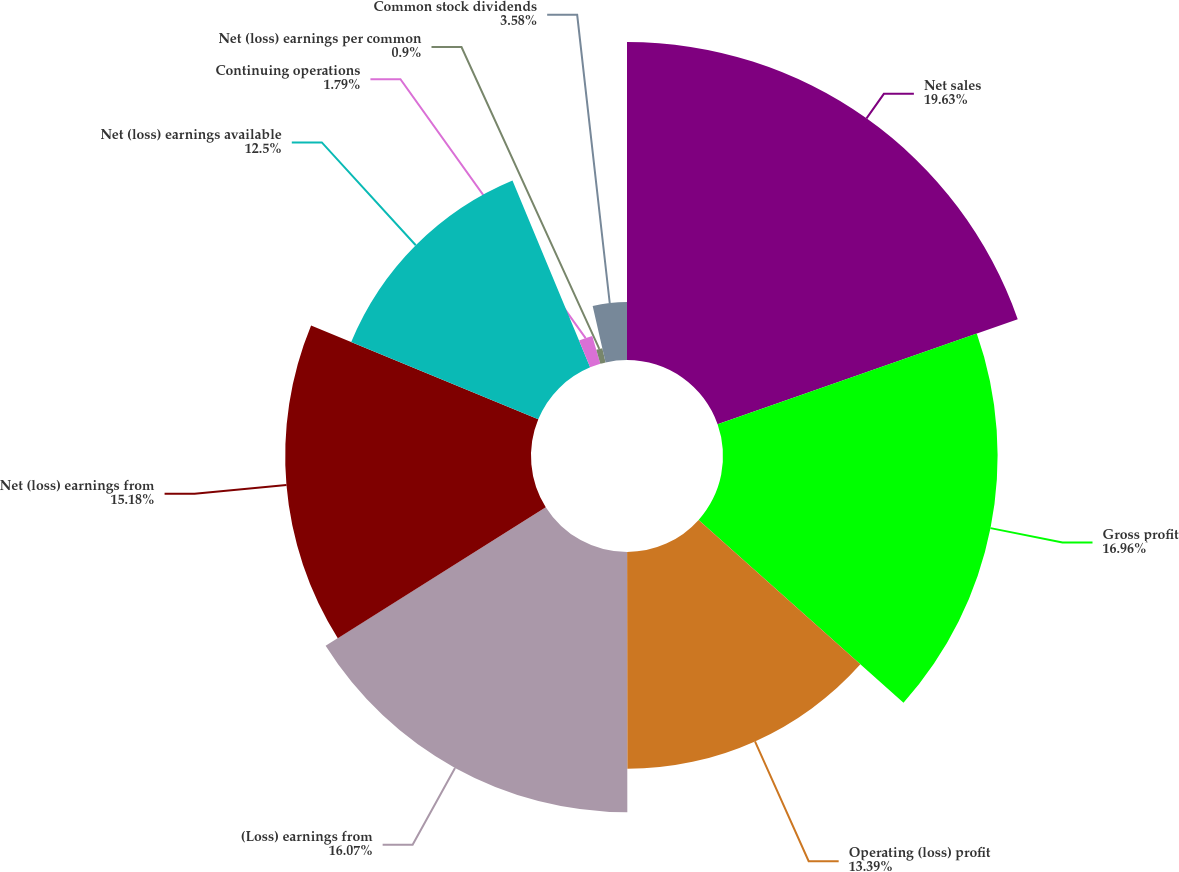Convert chart to OTSL. <chart><loc_0><loc_0><loc_500><loc_500><pie_chart><fcel>Net sales<fcel>Gross profit<fcel>Operating (loss) profit<fcel>(Loss) earnings from<fcel>Net (loss) earnings from<fcel>Net (loss) earnings available<fcel>Continuing operations<fcel>Net (loss) earnings per common<fcel>Common stock dividends<nl><fcel>19.64%<fcel>16.96%<fcel>13.39%<fcel>16.07%<fcel>15.18%<fcel>12.5%<fcel>1.79%<fcel>0.9%<fcel>3.58%<nl></chart> 